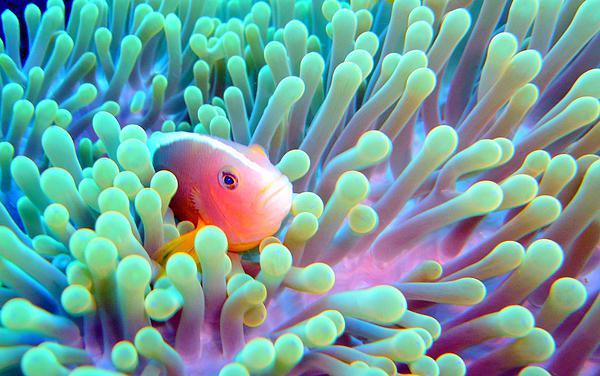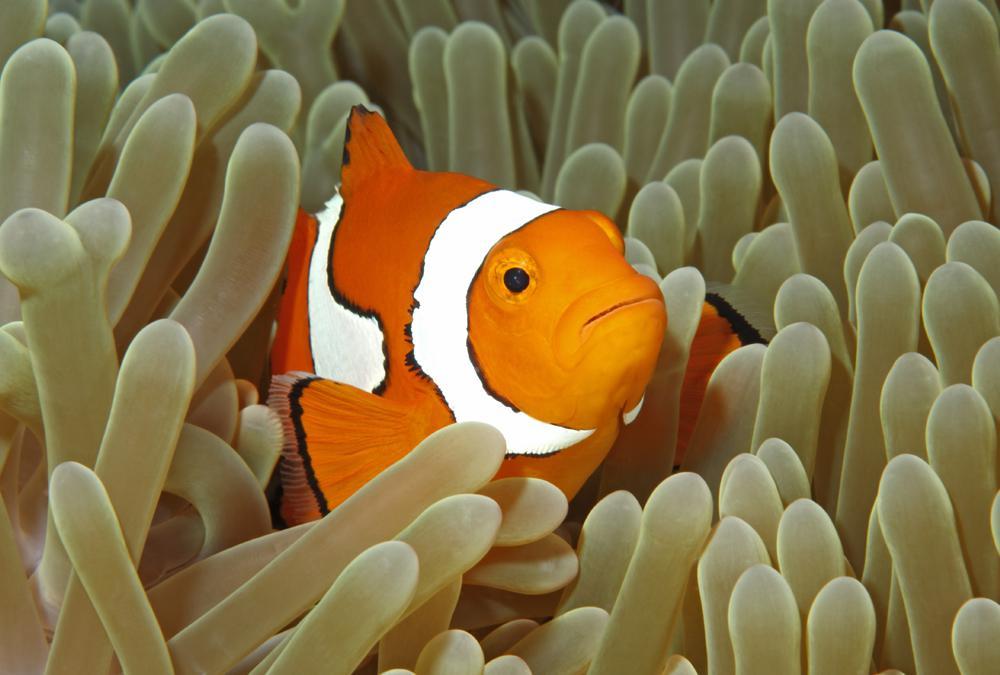The first image is the image on the left, the second image is the image on the right. For the images shown, is this caption "An image shows exactly one clownfish swimming near neutral-colored anemone tendrils." true? Answer yes or no. Yes. The first image is the image on the left, the second image is the image on the right. For the images shown, is this caption "The right image contains exactly one clown fish." true? Answer yes or no. Yes. 